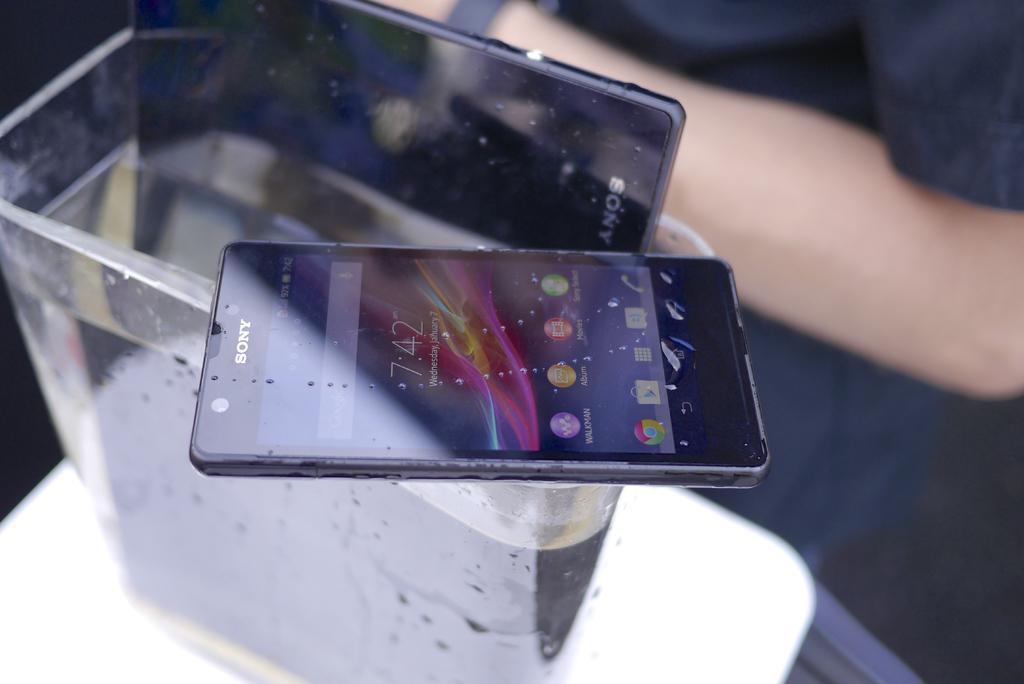How would you summarize this image in a sentence or two? In this image there is a glass on a plate. The glass is filled with the liquid. There is a mobile on the glass. Another mobile is kept on in the liquid which is in the glass. Right side there is a person. 